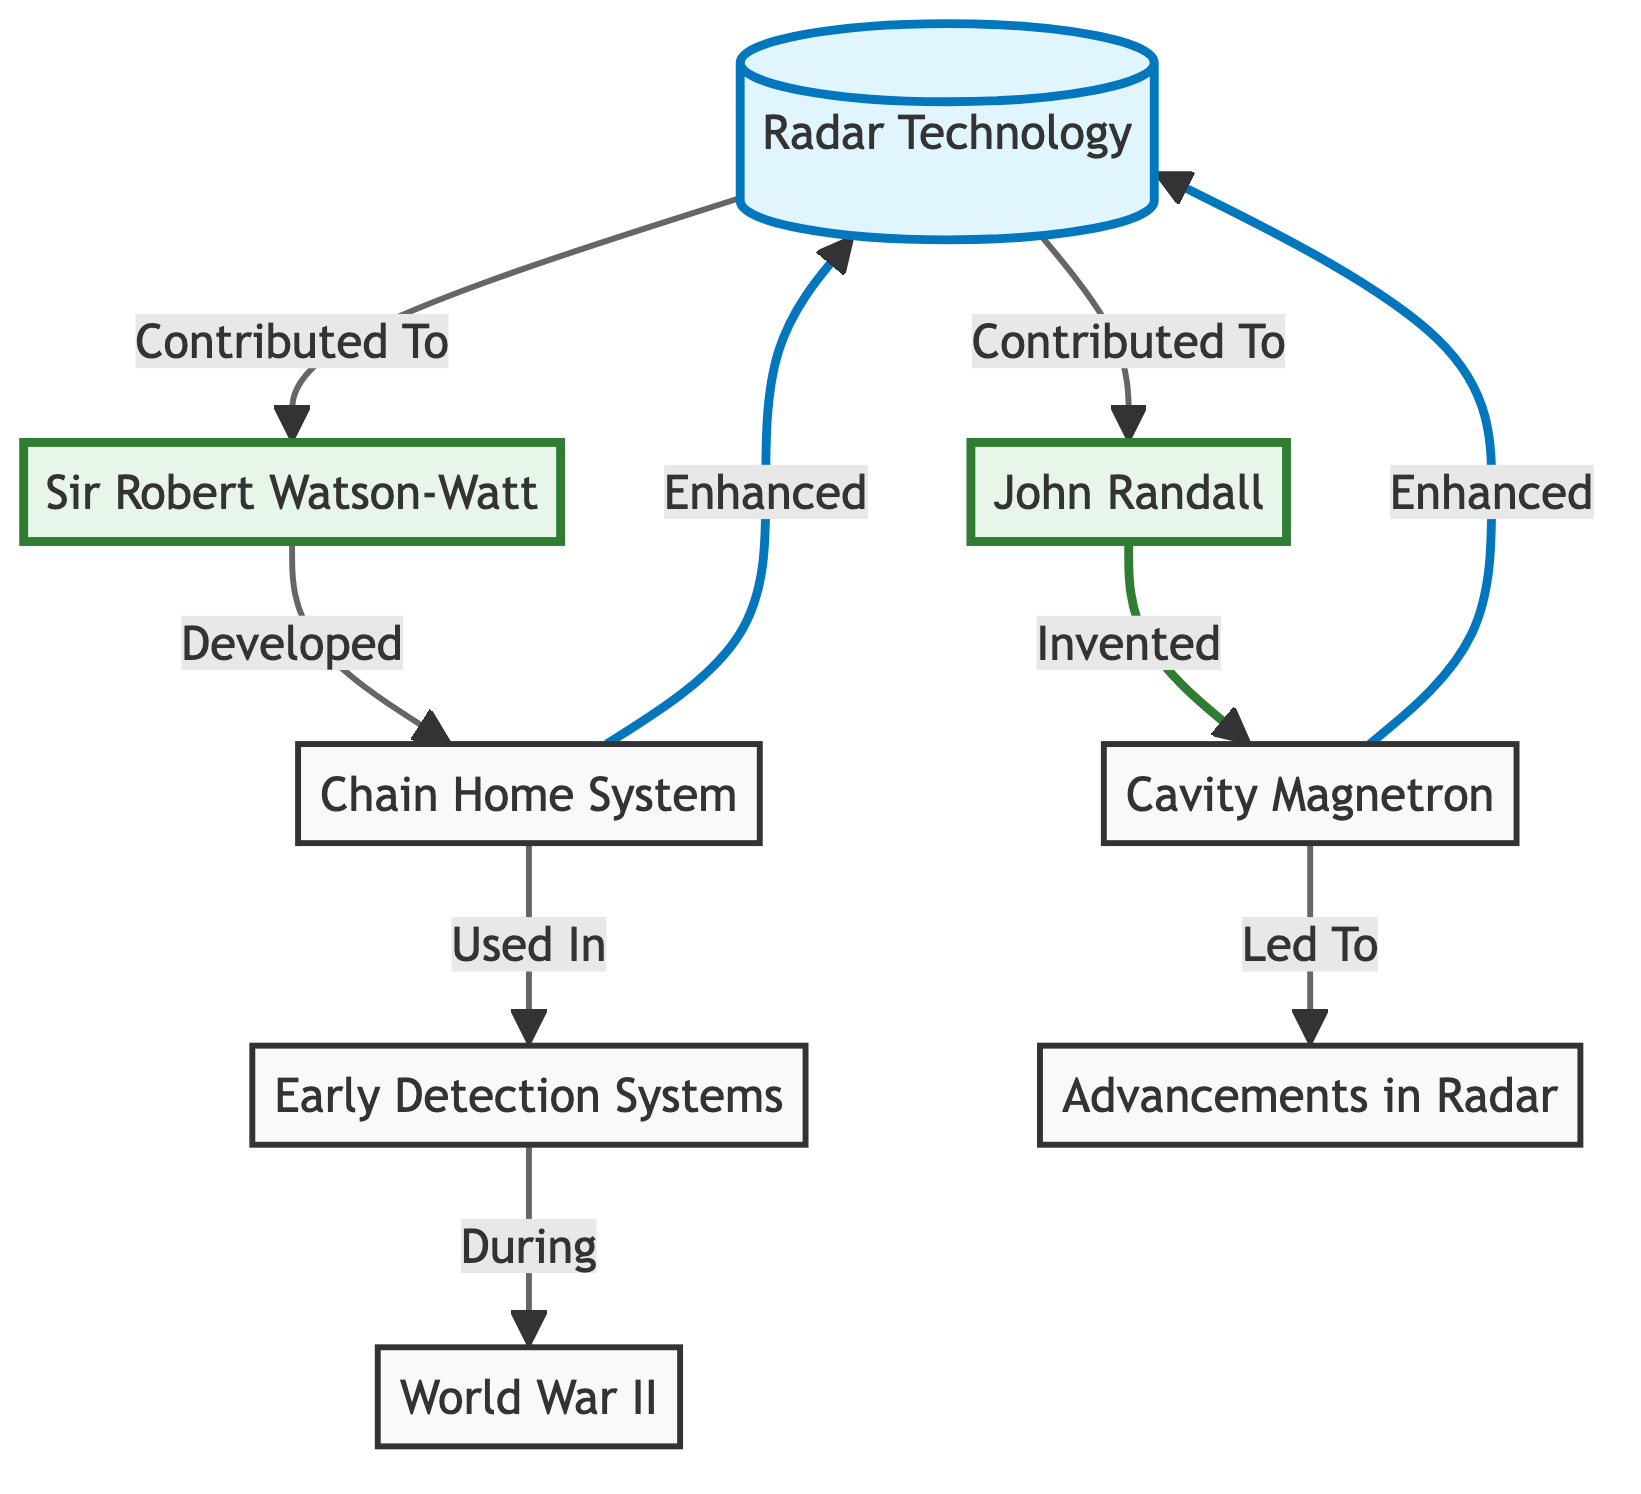What is the main technology discussed in the diagram? The diagram highlights "Radar Technology" as the central concept, categorized under the node labeled "Radar Technology" which connects various contributors and innovations in the field.
Answer: Radar Technology Who developed the Chain Home System? The diagram indicates that "Sir Robert Watson-Watt" is the figure associated with the development of the "Chain Home System," as shown by the directed arrow connecting these two nodes.
Answer: Sir Robert Watson-Watt What innovation did John Randall invent? The diagram specifies that John Randall is credited with the invention of the "Cavity Magnetron," representing a significant contribution within the radar technology context.
Answer: Cavity Magnetron What was the role of the Chain Home System during World War II? According to the diagram, the "Chain Home System" was used in "Early Detection Systems," especially during the context of World War II, as indicated by the directional flow linking these nodes.
Answer: Early Detection Systems How many key figures are highlighted in the diagram? The diagram features two key figures, identified as "Sir Robert Watson-Watt" and "John Randall," who are linked to the advancements in radar technology.
Answer: 2 What led to advancements in radar technology? The diagram depicts that the "Cavity Magnetron," invented by John Randall, played a crucial role that led to "Advancements in Radar," marking an important connection across the innovation chain.
Answer: Cavity Magnetron During which major event were Early Detection Systems utilized? The diagram provides information that "Early Detection Systems" were specifically used during "World War II," establishing a direct relationship between these two concepts.
Answer: World War II How did the Chain Home System enhance radar technology? The relationship shown in the diagram indicates that the "Chain Home System," developed by Sir Robert Watson-Watt, had the effect of "Enhanced" radar technology, demonstrating its importance in the evolution of radar.
Answer: Enhanced What enhanced radar technology according to the diagram? The diagram points out that the "Cavity Magnetron" invented by John Randall was a significant factor that enhanced the overall radar technology, pinpointing its essential role.
Answer: Cavity Magnetron 